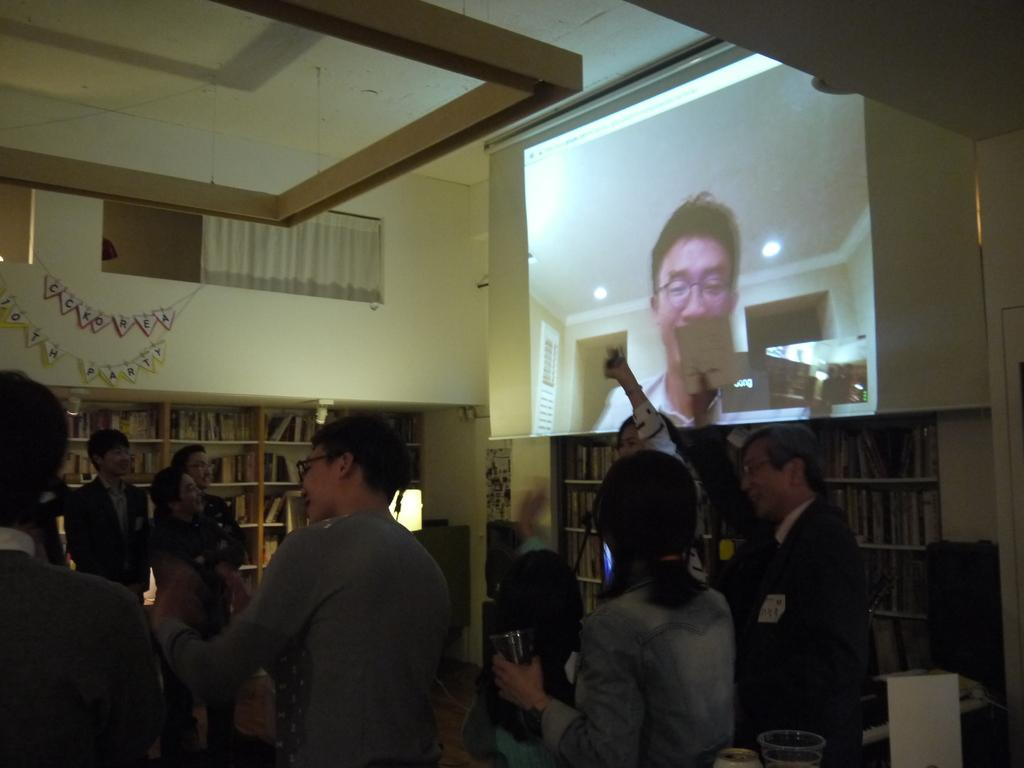What is the lady in the image holding? The lady is holding a glass in the image. What can be seen in the foreground area of the image? There are objects and people in the foreground area of the image. What type of furniture is visible in the background of the image? There are bookshelves in the background of the image. What architectural feature is present in the background of the image? There are windows in the background of the image. What type of electronic device is visible in the background of the image? There is a screen in the background of the image. What type of decorative items are visible in the background of the image? There are posters in the background of the image. What other objects can be seen in the background of the image? There are other objects in the background of the image. How many feet of jelly can be seen on the lady's head in the image? There is no jelly or feet present on the lady's head in the image. Is there an owl perched on the bookshelf in the background of the image? There is no owl present on the bookshelf or anywhere else in the image. 